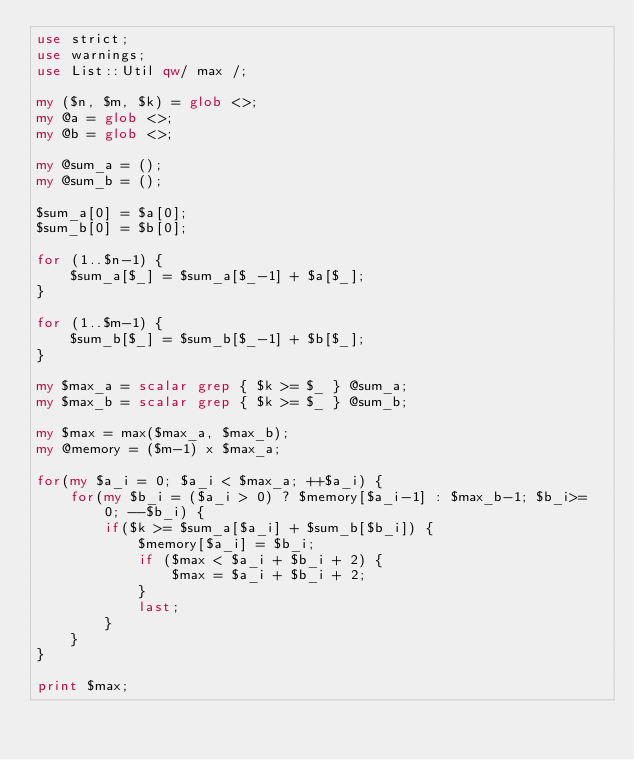<code> <loc_0><loc_0><loc_500><loc_500><_Perl_>use strict;
use warnings;
use List::Util qw/ max /;

my ($n, $m, $k) = glob <>;
my @a = glob <>;
my @b = glob <>;

my @sum_a = ();
my @sum_b = ();

$sum_a[0] = $a[0];
$sum_b[0] = $b[0];

for (1..$n-1) {
    $sum_a[$_] = $sum_a[$_-1] + $a[$_];
}

for (1..$m-1) {
    $sum_b[$_] = $sum_b[$_-1] + $b[$_];
}

my $max_a = scalar grep { $k >= $_ } @sum_a;
my $max_b = scalar grep { $k >= $_ } @sum_b;

my $max = max($max_a, $max_b);
my @memory = ($m-1) x $max_a;

for(my $a_i = 0; $a_i < $max_a; ++$a_i) {
    for(my $b_i = ($a_i > 0) ? $memory[$a_i-1] : $max_b-1; $b_i>= 0; --$b_i) {
        if($k >= $sum_a[$a_i] + $sum_b[$b_i]) {
            $memory[$a_i] = $b_i;
            if ($max < $a_i + $b_i + 2) {
                $max = $a_i + $b_i + 2;
            }
            last;
        }
    }
}

print $max;</code> 